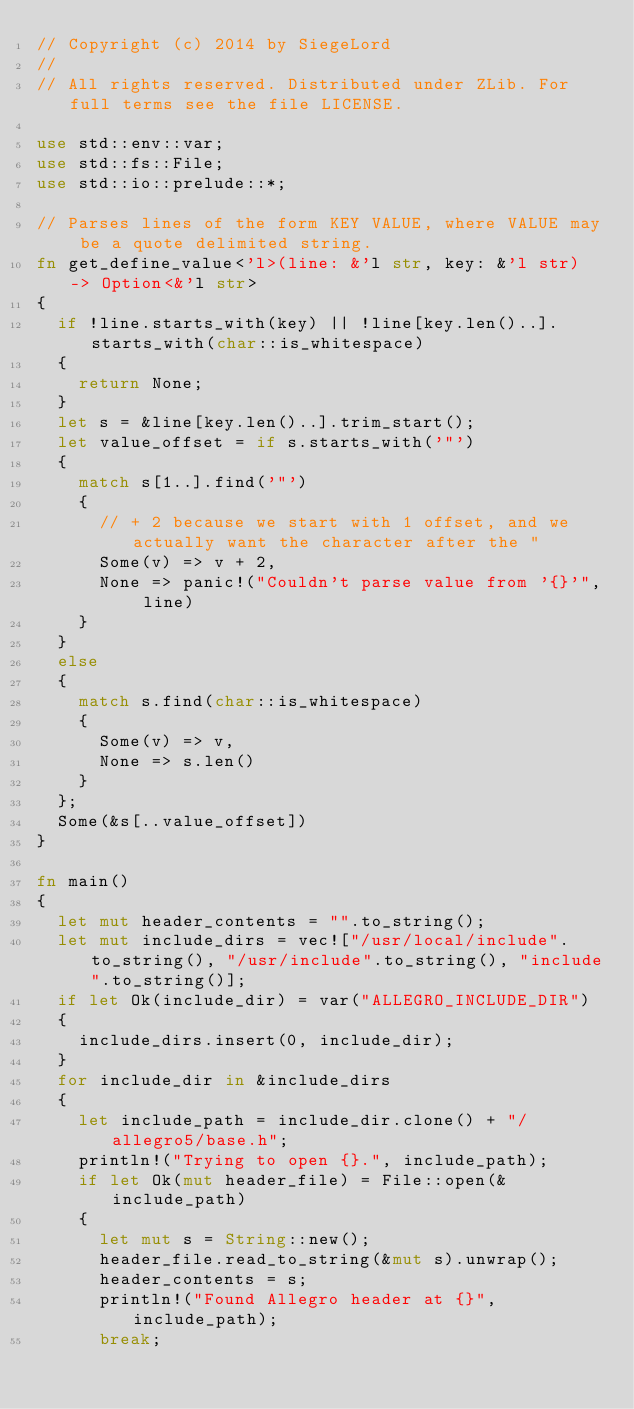Convert code to text. <code><loc_0><loc_0><loc_500><loc_500><_Rust_>// Copyright (c) 2014 by SiegeLord
//
// All rights reserved. Distributed under ZLib. For full terms see the file LICENSE.

use std::env::var;
use std::fs::File;
use std::io::prelude::*;

// Parses lines of the form KEY VALUE, where VALUE may be a quote delimited string.
fn get_define_value<'l>(line: &'l str, key: &'l str) -> Option<&'l str>
{
	if !line.starts_with(key) || !line[key.len()..].starts_with(char::is_whitespace)
	{
		return None;
	}
	let s = &line[key.len()..].trim_start();
	let value_offset = if s.starts_with('"')
	{
		match s[1..].find('"')
		{
			// + 2 because we start with 1 offset, and we actually want the character after the "
			Some(v) => v + 2,
			None => panic!("Couldn't parse value from '{}'", line)
		}
	}
	else
	{
		match s.find(char::is_whitespace)
		{
			Some(v) => v,
			None => s.len()
		}
	};
	Some(&s[..value_offset])
}

fn main()
{
	let mut header_contents = "".to_string();
	let mut include_dirs = vec!["/usr/local/include".to_string(), "/usr/include".to_string(), "include".to_string()];
	if let Ok(include_dir) = var("ALLEGRO_INCLUDE_DIR")
	{
		include_dirs.insert(0, include_dir);
	}
	for include_dir in &include_dirs
	{
		let include_path = include_dir.clone() + "/allegro5/base.h";
		println!("Trying to open {}.", include_path);
		if let Ok(mut header_file) = File::open(&include_path)
		{
			let mut s = String::new();
			header_file.read_to_string(&mut s).unwrap();
			header_contents = s;
			println!("Found Allegro header at {}", include_path);
			break;</code> 